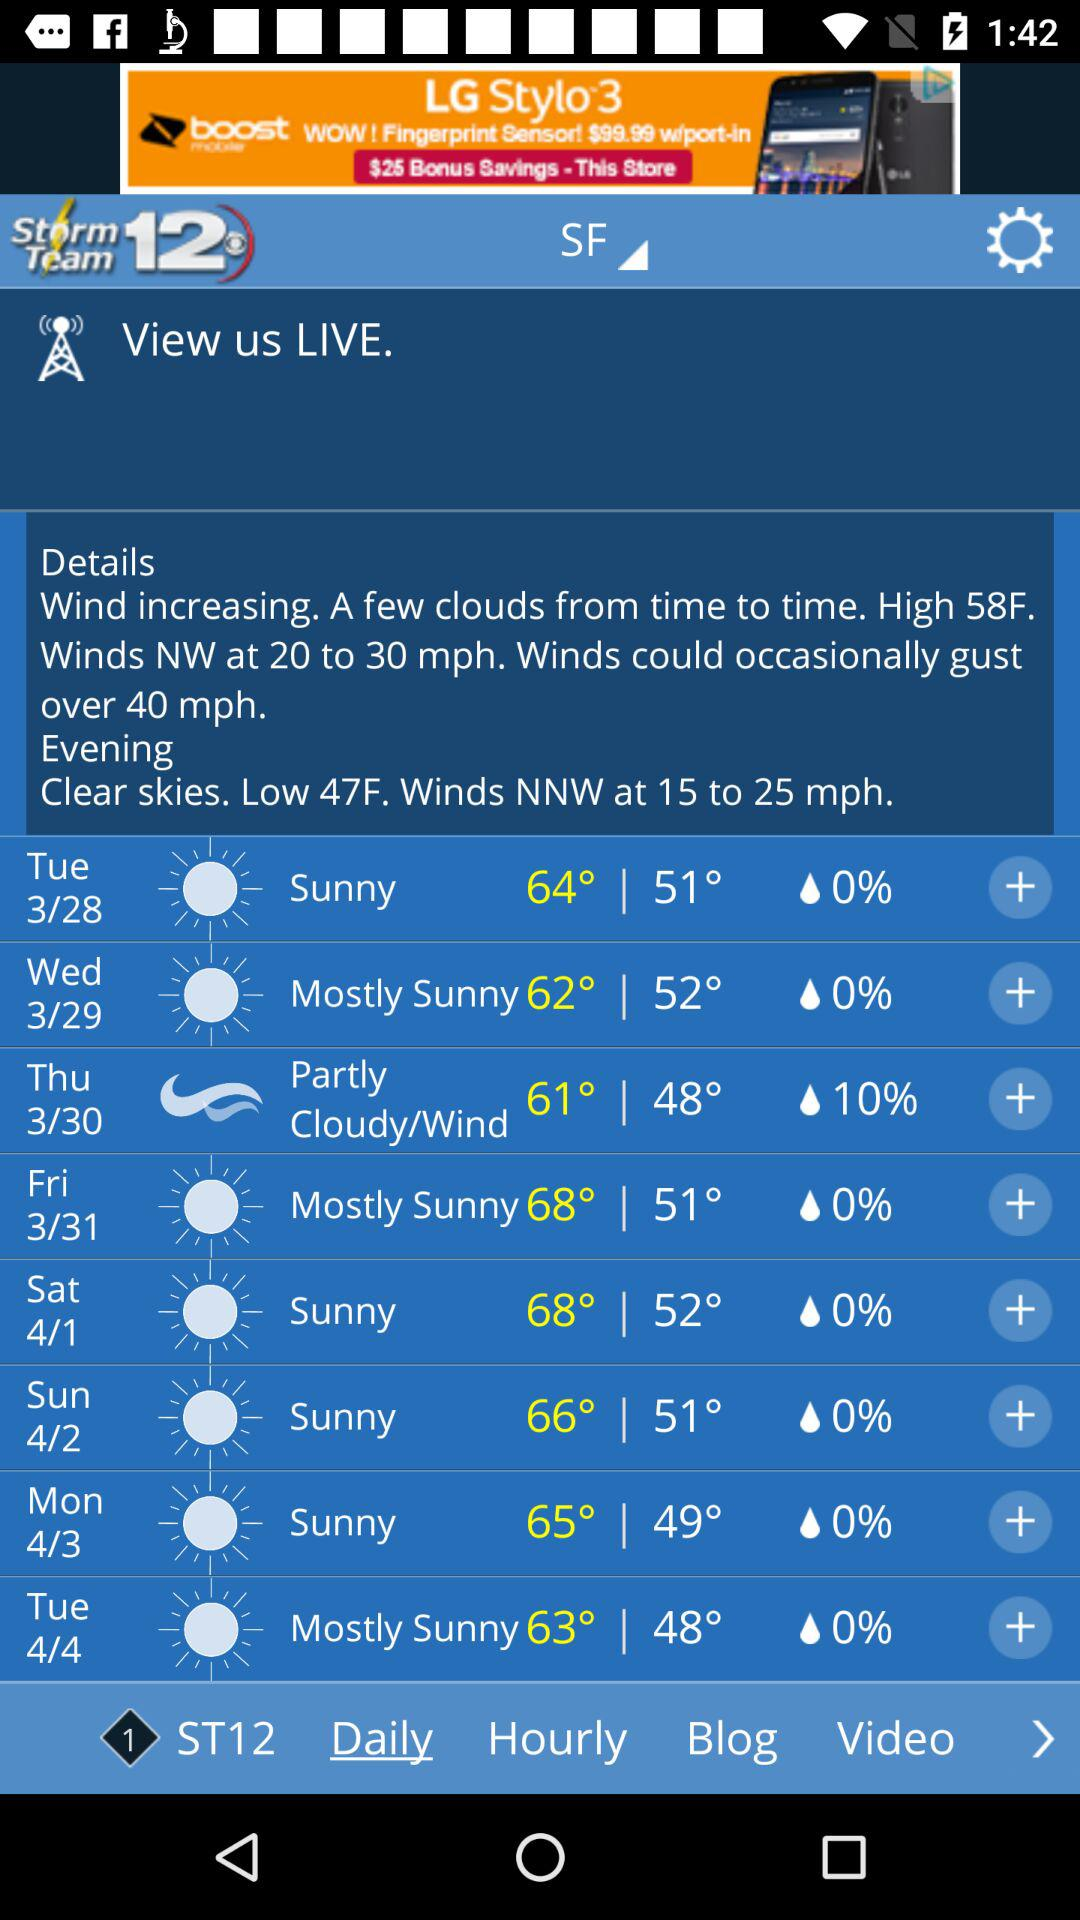What is the high temperature for Wednesday?
Answer the question using a single word or phrase. 62° 